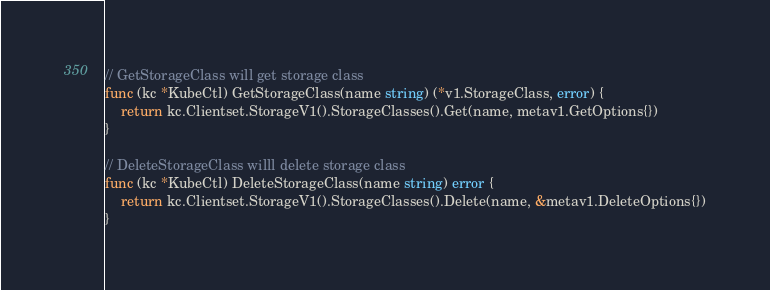<code> <loc_0><loc_0><loc_500><loc_500><_Go_>// GetStorageClass will get storage class
func (kc *KubeCtl) GetStorageClass(name string) (*v1.StorageClass, error) {
	return kc.Clientset.StorageV1().StorageClasses().Get(name, metav1.GetOptions{})
}

// DeleteStorageClass willl delete storage class
func (kc *KubeCtl) DeleteStorageClass(name string) error {
	return kc.Clientset.StorageV1().StorageClasses().Delete(name, &metav1.DeleteOptions{})
}
</code> 